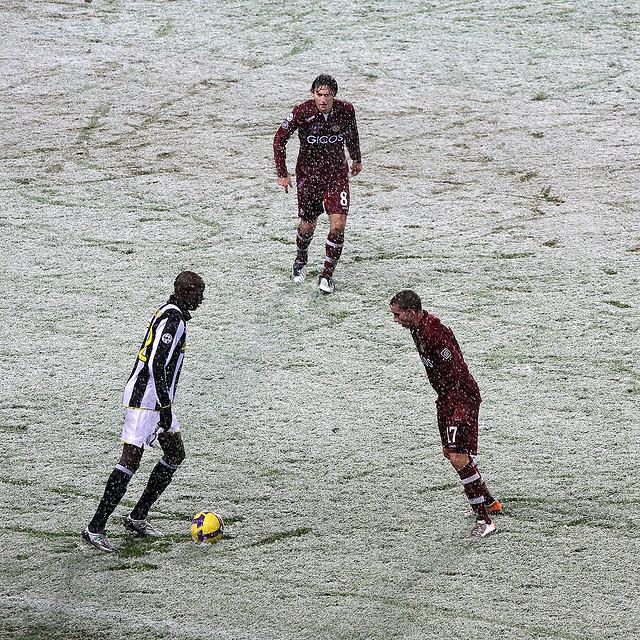What substance is covering the turf? Please explain your reasoning. snow. The players appear to be outside and it's not uncommon for snow to fall. 